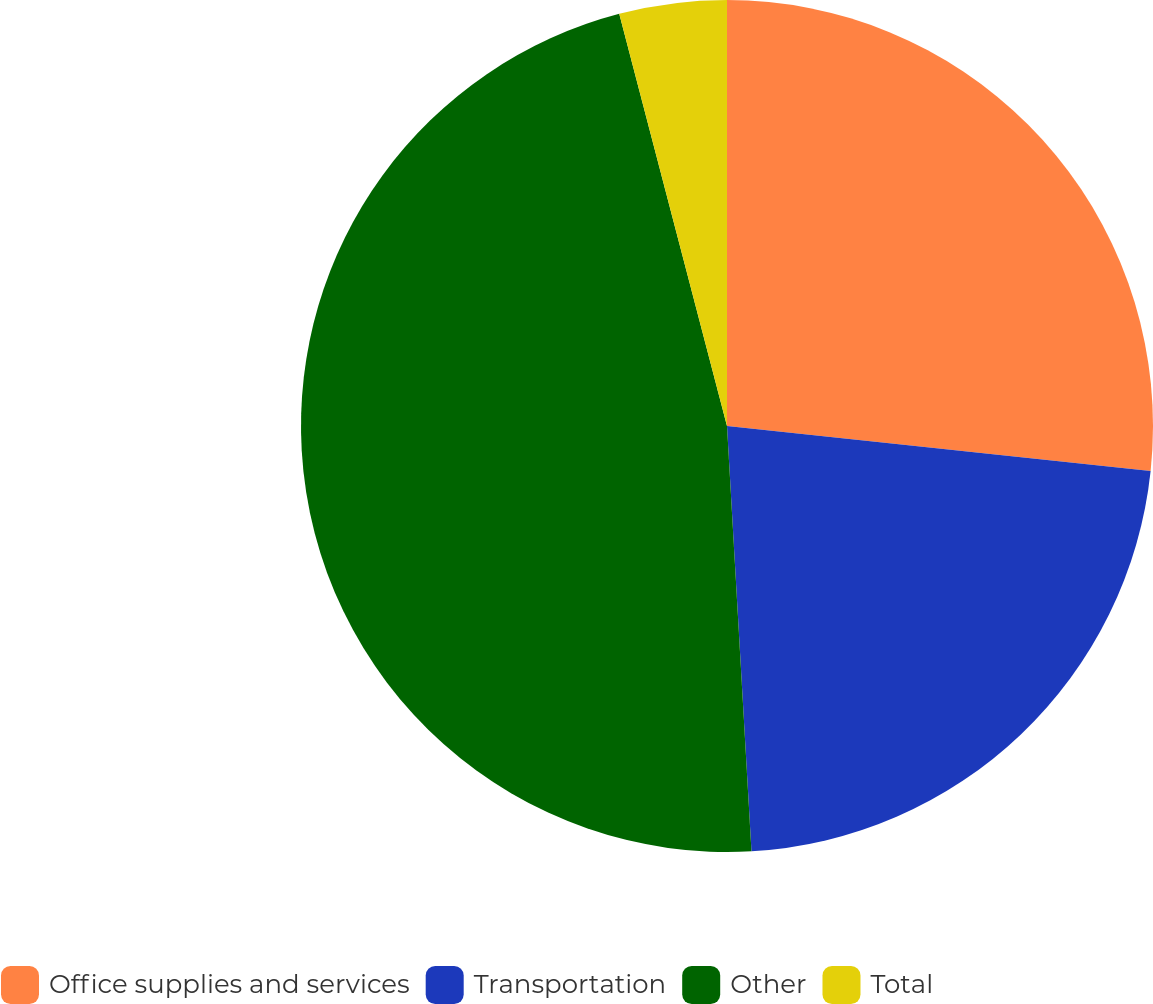Convert chart to OTSL. <chart><loc_0><loc_0><loc_500><loc_500><pie_chart><fcel>Office supplies and services<fcel>Transportation<fcel>Other<fcel>Total<nl><fcel>26.68%<fcel>22.4%<fcel>46.84%<fcel>4.07%<nl></chart> 